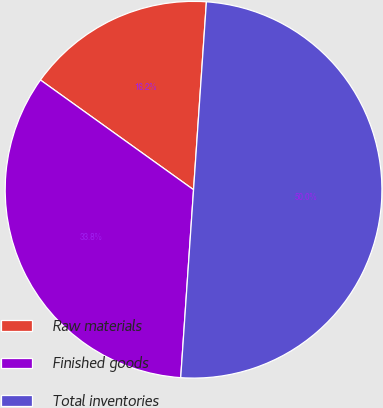<chart> <loc_0><loc_0><loc_500><loc_500><pie_chart><fcel>Raw materials<fcel>Finished goods<fcel>Total inventories<nl><fcel>16.19%<fcel>33.81%<fcel>50.0%<nl></chart> 